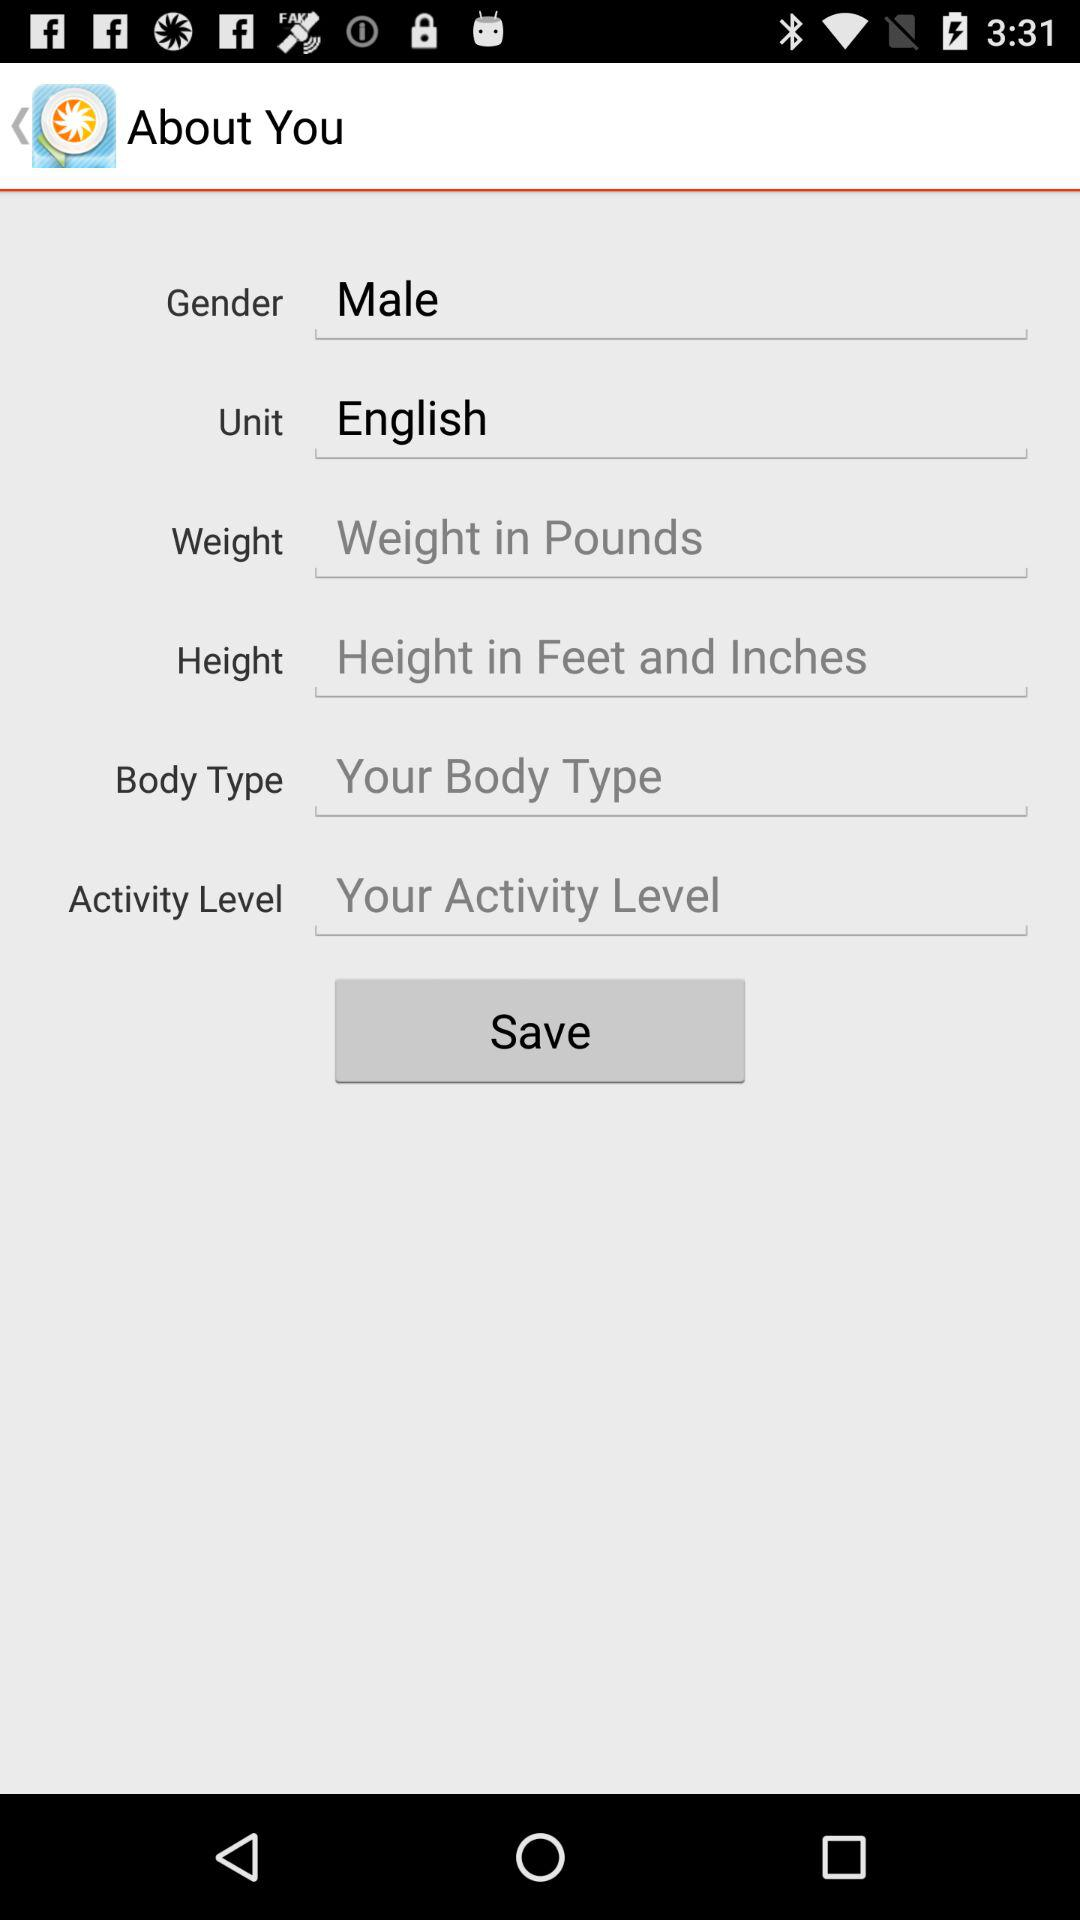What is the selected unit? The selected unit is "English". 